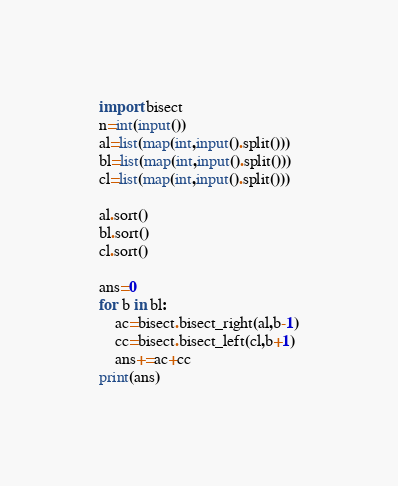<code> <loc_0><loc_0><loc_500><loc_500><_Python_>import bisect
n=int(input())
al=list(map(int,input().split()))
bl=list(map(int,input().split()))
cl=list(map(int,input().split()))

al.sort()
bl.sort()
cl.sort()

ans=0
for b in bl:
    ac=bisect.bisect_right(al,b-1)
    cc=bisect.bisect_left(cl,b+1)
    ans+=ac+cc
print(ans)

</code> 